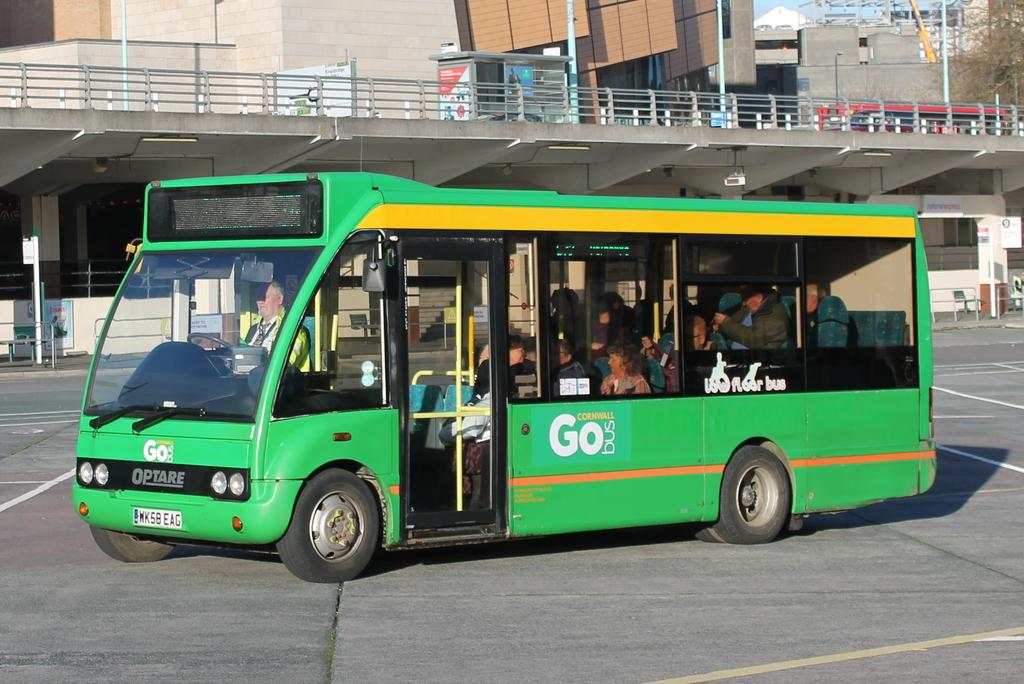Provide a one-sentence caption for the provided image. A green Optare bus sits filled with people, the words Go Bus are written on its side. 